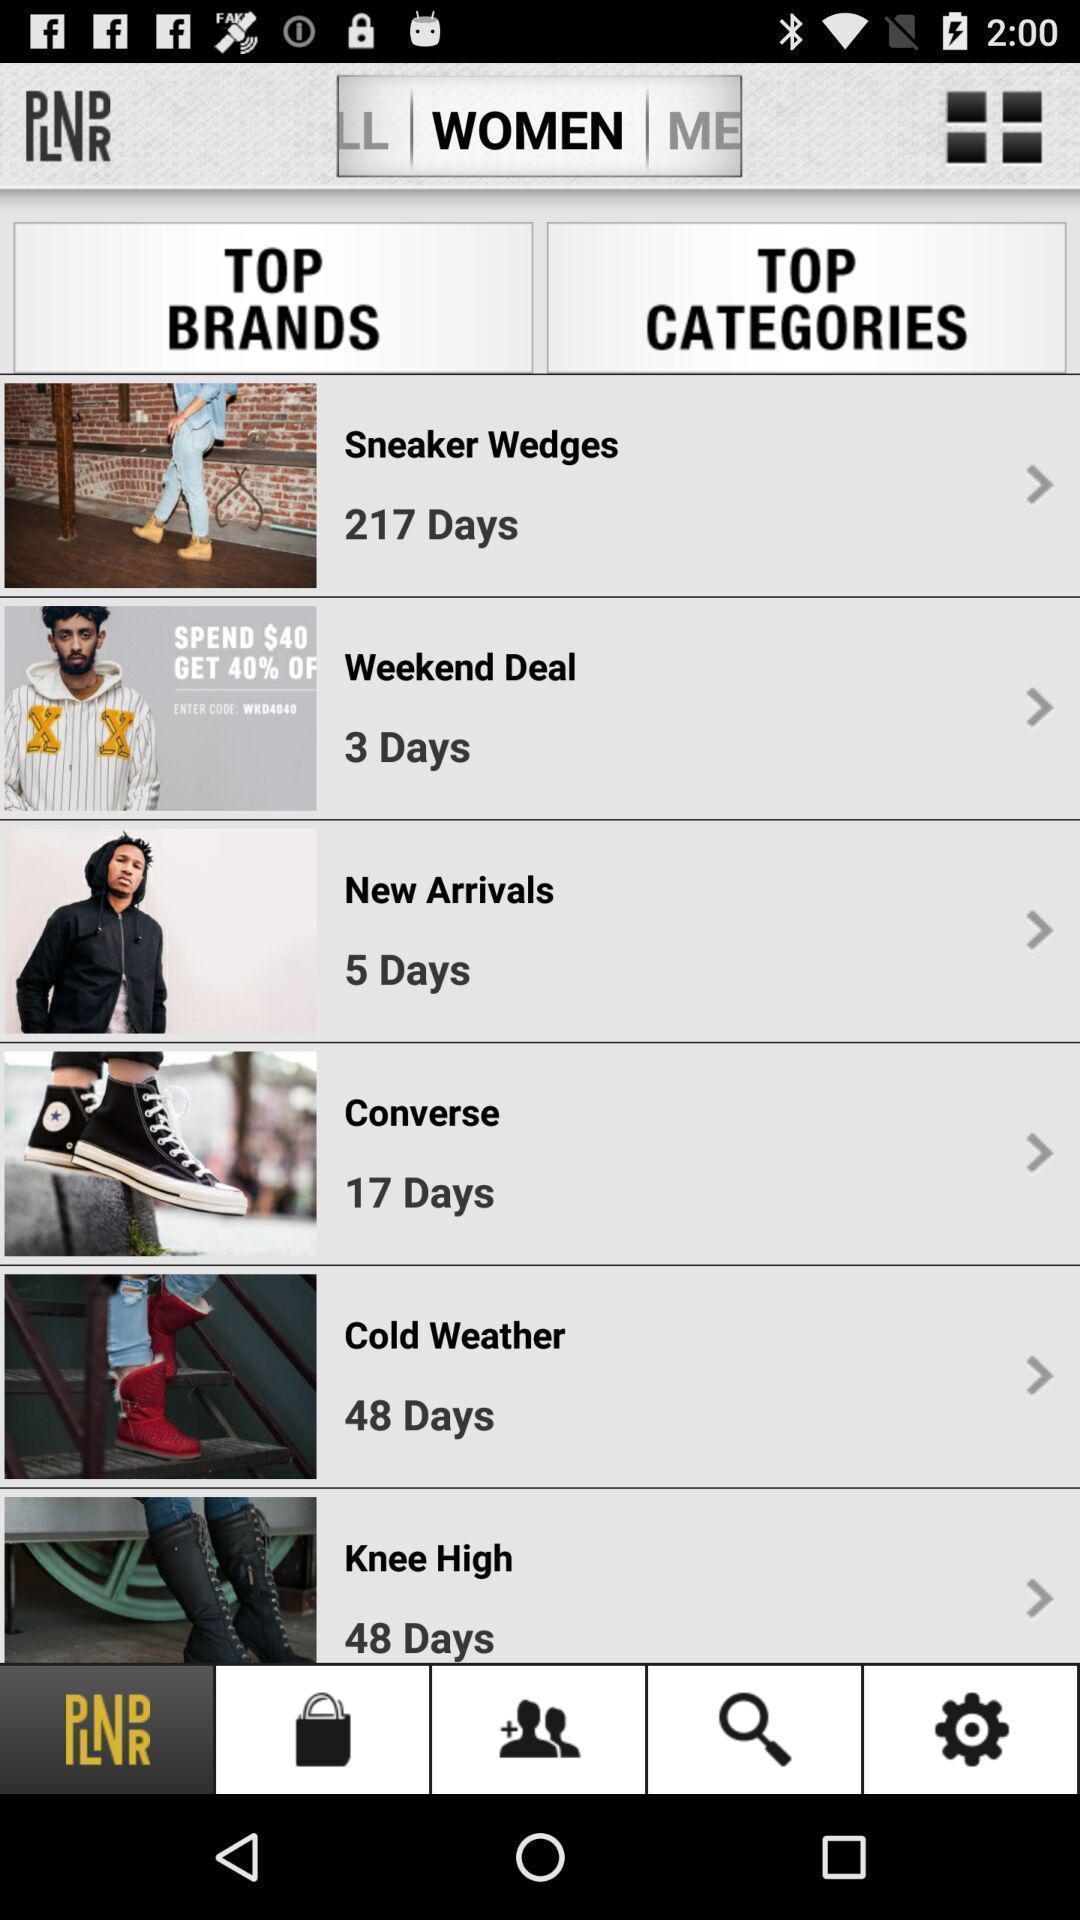Describe the visual elements of this screenshot. Screen showing top brands and top categories. 